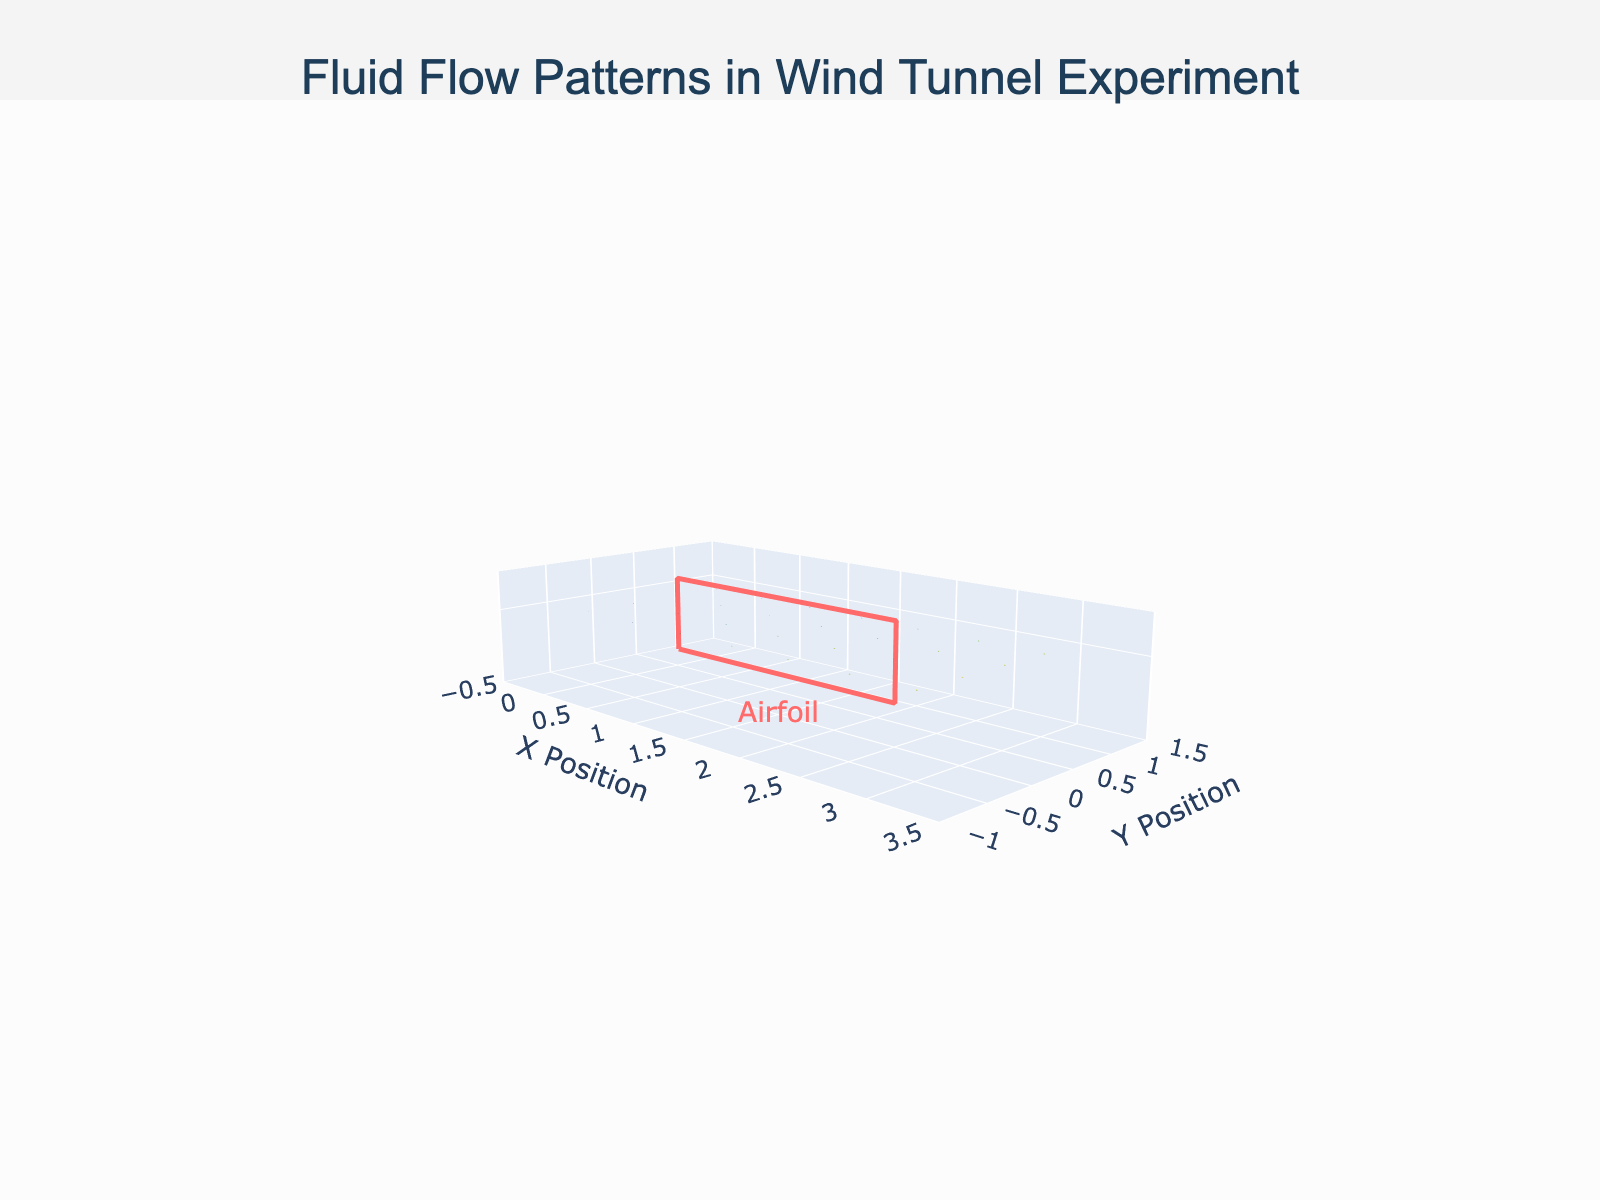What is the title of the figure? The title can be found at the top of the figure. It reads "Fluid Flow Patterns in Wind Tunnel Experiment".
Answer: Fluid Flow Patterns in Wind Tunnel Experiment What are the ranges for the x and y axes? The x-axis range is indicated from -0.5 to 3.5, and the y-axis range is from -1 to 1.5. You can see these values in the axis annotations.
Answer: x: -0.5 to 3.5, y: -1 to 1.5 How many velocity vectors are plotted in the figure? To determine the number of velocity vectors, count the data points listed in the dataset. There are 28 vectors in total.
Answer: 28 Where are the positions of the airfoil in the plot? The airfoil is marked by a rectangle, and its position is annotated. It spans from x = 0.5 to x = 2.5 and is centered around y = 0.
Answer: x: 0.5 to 2.5, y: 0 How does the velocity magnitude change around the airfoil from left to right? By examining the lengths of the arrows (velocity vectors) in the quiver plot, we can see that the velocity magnitude increases from left to right, reaching a maximum around the middle and then slowly decreasing towards the end.
Answer: Increases and then decreases What is the direction of the velocity vector at position (1, 1)? The vector at (1, 1) points horizontally to the right, indicating a direction towards the positive x-axis.
Answer: To the right Which position near the airfoil has the highest vertical velocity component? To find this, look at the vectors near the airfoil and compare their vertical components (v values). The highest vertical velocity component near the airfoil is at (1.5, -0.5), with v = 4.
Answer: (1.5, -0.5) Compare the velocity vectors at (1, 0) and (1, -0.5). Which one has a higher speed, and by how much? The velocity vector at (1, 0) has components (15, 2) and speed √(15^2 + 2^2) = √229 ≈ 15.1. The velocity vector at (1, -0.5) has components (14, 3) and speed √(14^2 + 3^2) = √205 ≈ 14.3. Therefore, the vector at (1, 0) has a higher speed by approximately 0.8 units.
Answer: (1, 0) by 0.8 units What is the pattern of the vertical velocities (v) as you move vertically at x = 2? At x = 2, the vertical velocities (v values) are 2 (y = 0), 1 (y = 0.5), 0 (y = 1), and 3 (y = -0.5), indicating that the vertical component decreases moving up and increases moving down.
Answer: Decreases moving up, increases moving down 